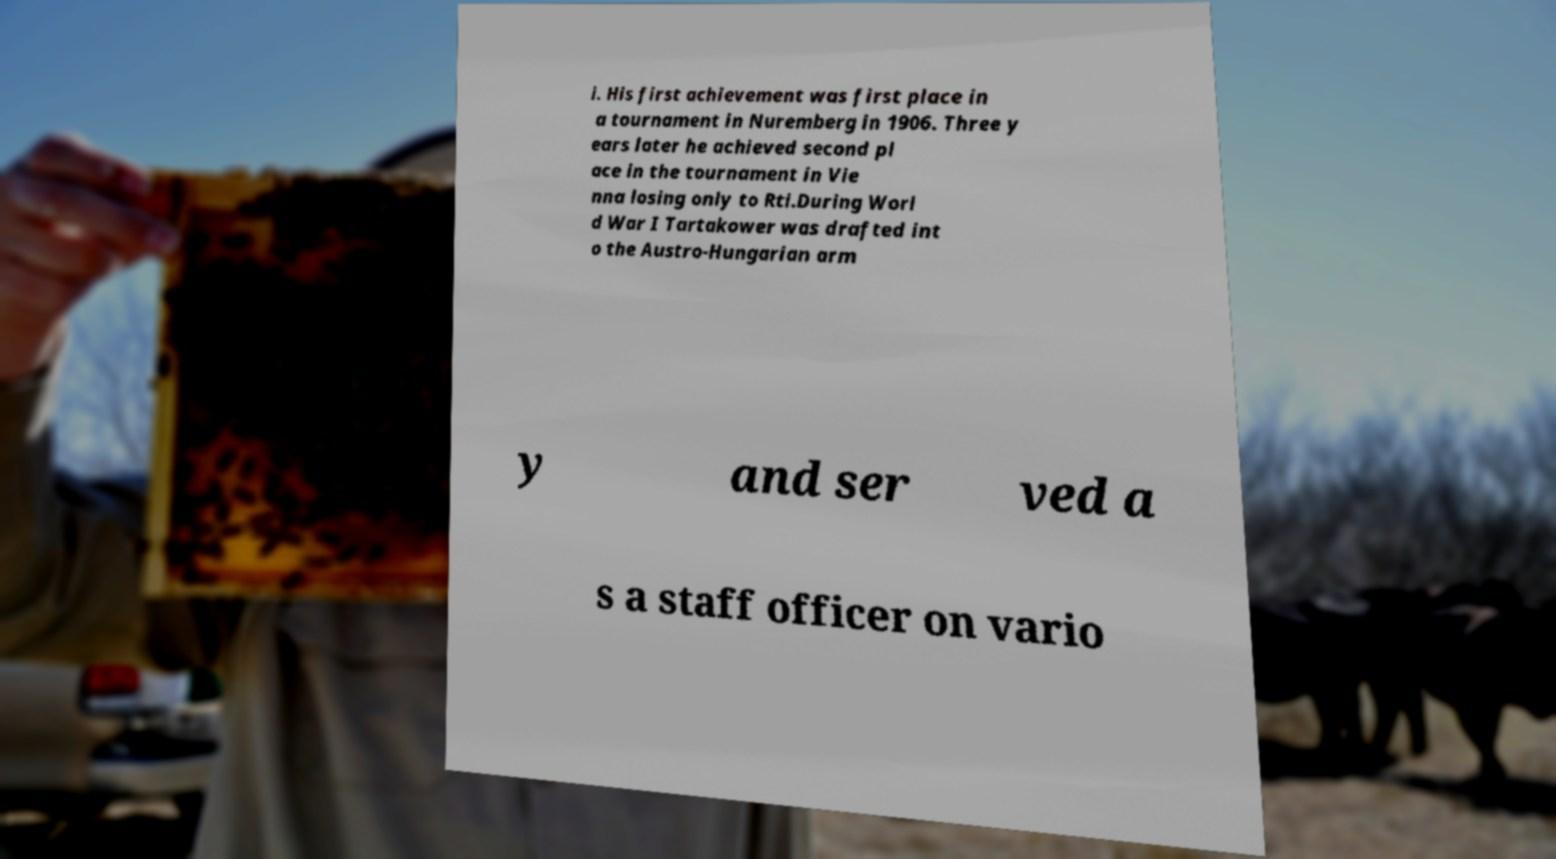Please read and relay the text visible in this image. What does it say? i. His first achievement was first place in a tournament in Nuremberg in 1906. Three y ears later he achieved second pl ace in the tournament in Vie nna losing only to Rti.During Worl d War I Tartakower was drafted int o the Austro-Hungarian arm y and ser ved a s a staff officer on vario 